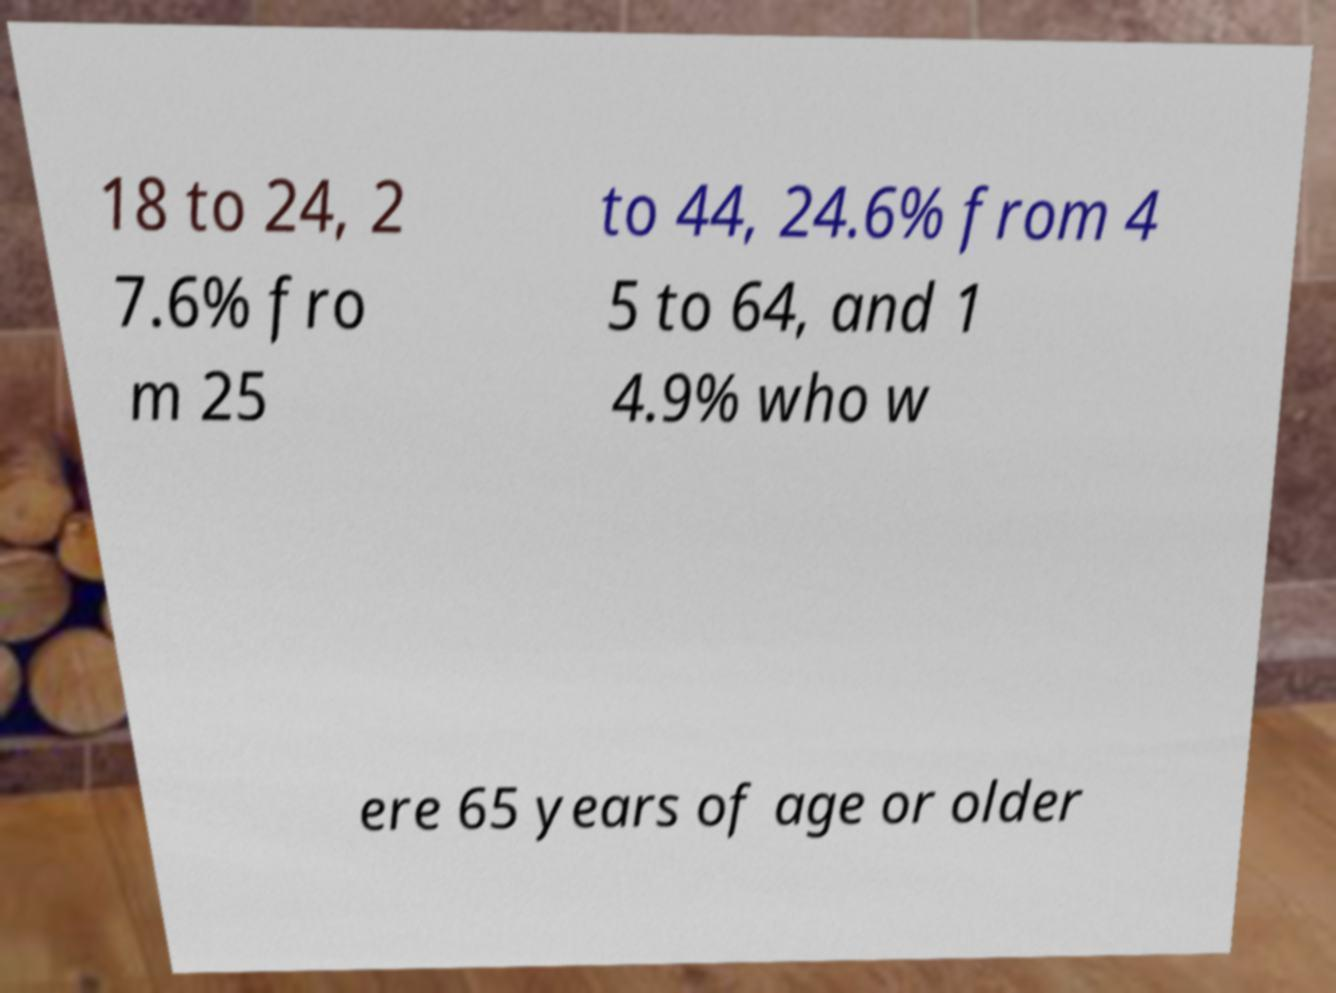There's text embedded in this image that I need extracted. Can you transcribe it verbatim? 18 to 24, 2 7.6% fro m 25 to 44, 24.6% from 4 5 to 64, and 1 4.9% who w ere 65 years of age or older 